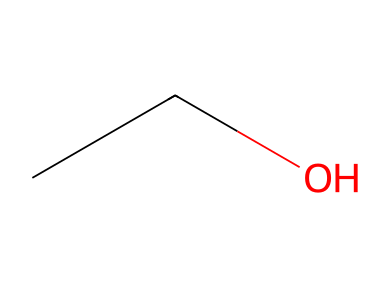What is the name of this chemical? The SMILES representation "CCO" corresponds to ethanol, which is a two-carbon alcohol.
Answer: ethanol How many carbon atoms are present in this molecule? The SMILES representation shows two "C" characters, indicating that there are two carbon atoms in the molecule.
Answer: 2 What type of functional group is present in ethanol? The "O" at the end of the SMILES representation indicates the presence of a hydroxyl (-OH) group, which classifies ethanol as an alcohol.
Answer: hydroxyl Is this chemical considered hazardous? Ethanol is classified as a hazardous material, particularly in high concentrations due to its flammability and potential health effects when ingested or inhaled.
Answer: yes What is the molecular formula of this compound? Considering the atoms present, ethanol has two carbon atoms, six hydrogen atoms, and one oxygen atom, leading to the molecular formula C2H6O.
Answer: C2H6O Why is ethanol used in book cleaning and conservation? Ethanol is effective due to its solvent properties, which can dissolve oils, inks, and other contaminants without damaging paper, and it also has antimicrobial properties.
Answer: effective solvent 